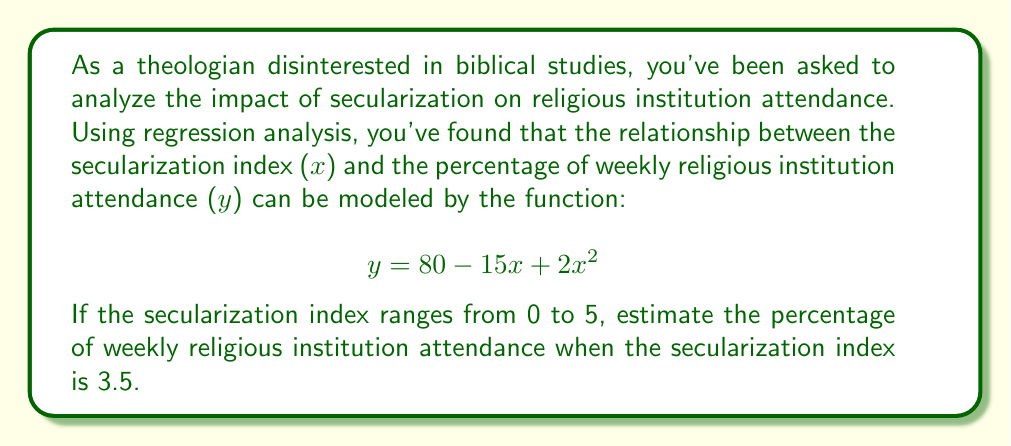Provide a solution to this math problem. To solve this problem, we need to follow these steps:

1. Understand the given function:
   $$ y = 80 - 15x + 2x^2 $$
   Where y is the percentage of weekly religious institution attendance and x is the secularization index.

2. Substitute the given value of x = 3.5 into the function:
   $$ y = 80 - 15(3.5) + 2(3.5)^2 $$

3. Simplify the expression:
   $$ y = 80 - 52.5 + 2(12.25) $$
   $$ y = 80 - 52.5 + 24.5 $$

4. Perform the arithmetic:
   $$ y = 52 $$

The result shows that when the secularization index is 3.5, the estimated percentage of weekly religious institution attendance is 52%.

It's worth noting that this quadratic function suggests a more complex relationship between secularization and attendance than a simple linear decline. The positive coefficient of the x² term indicates that at higher levels of secularization, the rate of decline in attendance may slow down or even reverse slightly.
Answer: 52% 